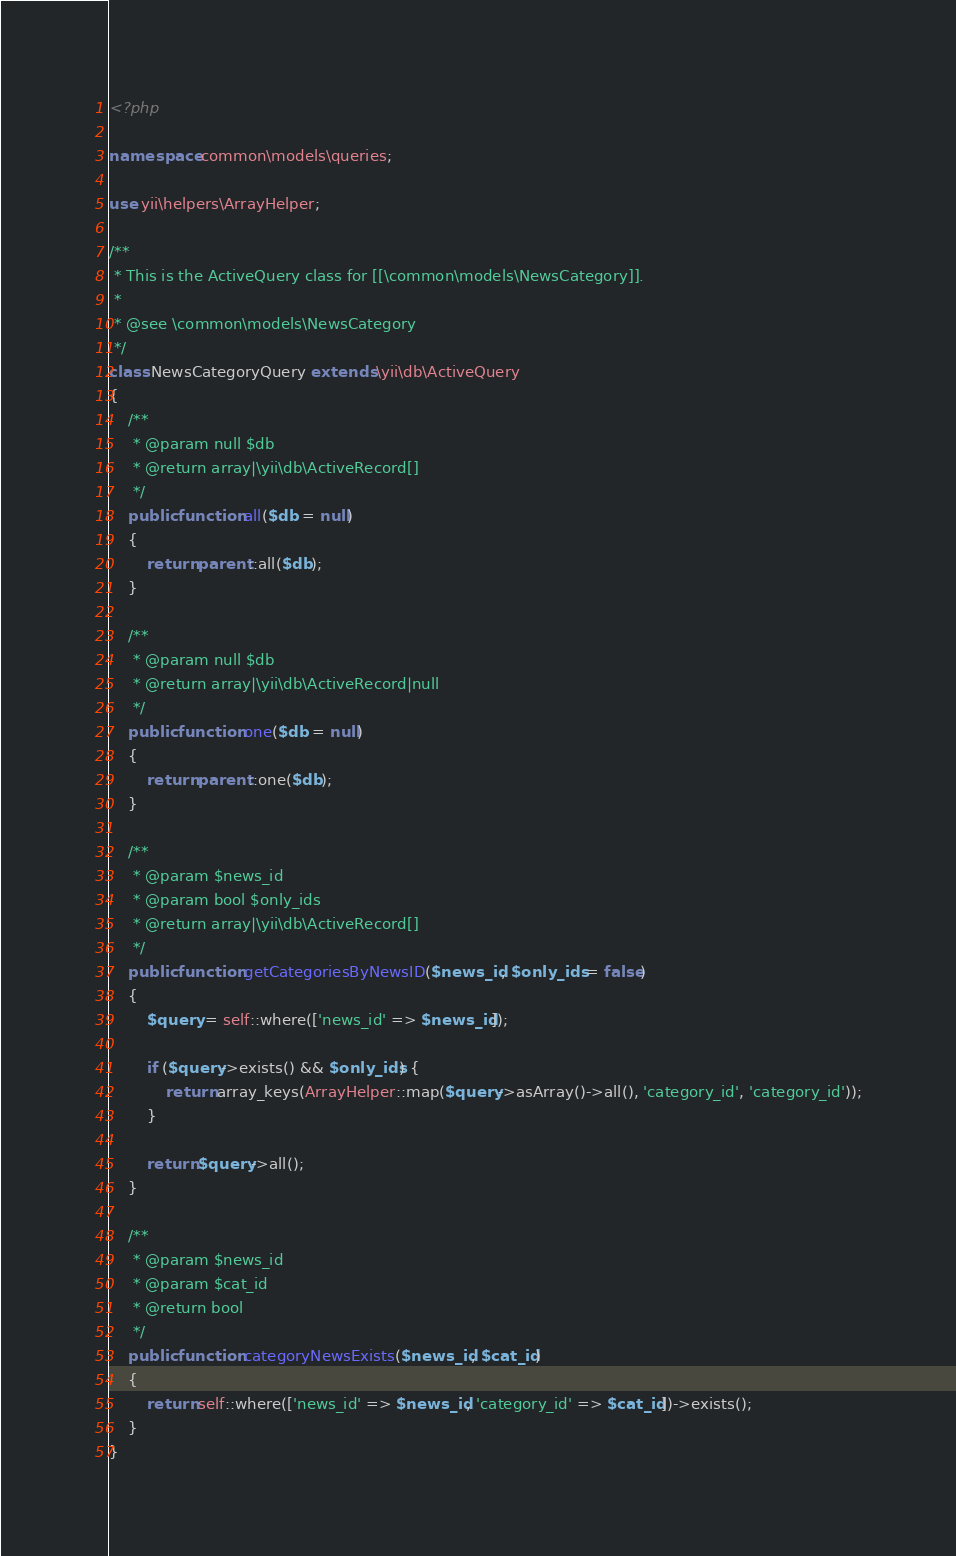<code> <loc_0><loc_0><loc_500><loc_500><_PHP_><?php

namespace common\models\queries;

use yii\helpers\ArrayHelper;

/**
 * This is the ActiveQuery class for [[\common\models\NewsCategory]].
 *
 * @see \common\models\NewsCategory
 */
class NewsCategoryQuery extends \yii\db\ActiveQuery
{
    /**
     * @param null $db
     * @return array|\yii\db\ActiveRecord[]
     */
    public function all($db = null)
    {
        return parent::all($db);
    }

    /**
     * @param null $db
     * @return array|\yii\db\ActiveRecord|null
     */
    public function one($db = null)
    {
        return parent::one($db);
    }

    /**
     * @param $news_id
     * @param bool $only_ids
     * @return array|\yii\db\ActiveRecord[]
     */
    public function getCategoriesByNewsID($news_id, $only_ids = false)
    {
        $query = self::where(['news_id' => $news_id]);

        if ($query->exists() && $only_ids) {
            return array_keys(ArrayHelper::map($query->asArray()->all(), 'category_id', 'category_id'));
        }

        return $query->all();
    }

    /**
     * @param $news_id
     * @param $cat_id
     * @return bool
     */
    public function categoryNewsExists($news_id, $cat_id)
    {
        return self::where(['news_id' => $news_id, 'category_id' => $cat_id])->exists();
    }
}
</code> 